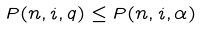<formula> <loc_0><loc_0><loc_500><loc_500>P ( n , i , q ) \leq P ( n , i , \alpha )</formula> 